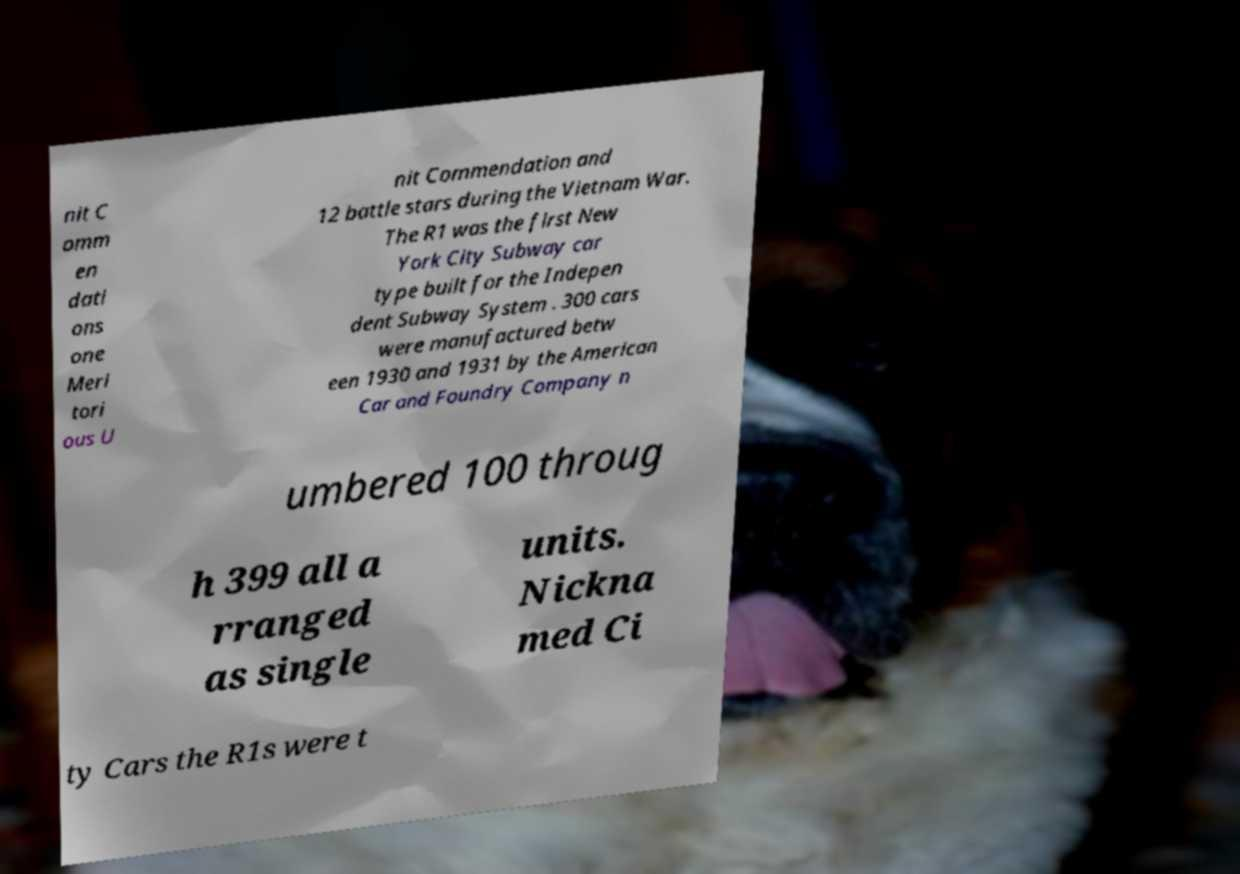Please read and relay the text visible in this image. What does it say? nit C omm en dati ons one Meri tori ous U nit Commendation and 12 battle stars during the Vietnam War. The R1 was the first New York City Subway car type built for the Indepen dent Subway System . 300 cars were manufactured betw een 1930 and 1931 by the American Car and Foundry Company n umbered 100 throug h 399 all a rranged as single units. Nickna med Ci ty Cars the R1s were t 